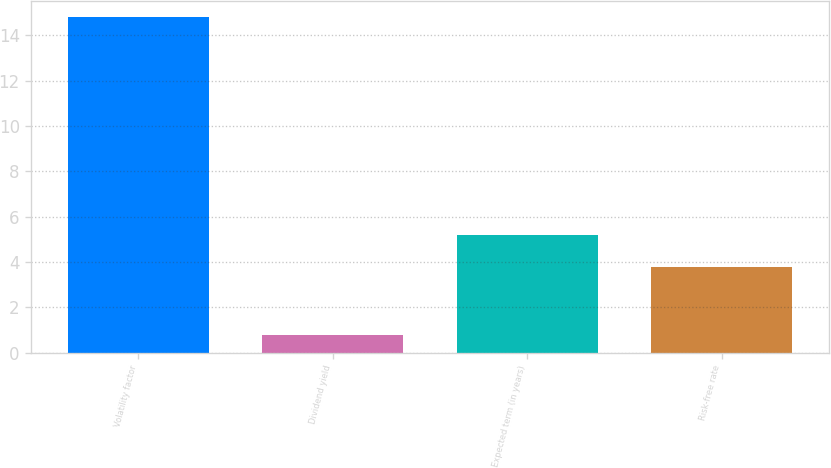<chart> <loc_0><loc_0><loc_500><loc_500><bar_chart><fcel>Volatility factor<fcel>Dividend yield<fcel>Expected term (in years)<fcel>Risk-free rate<nl><fcel>14.8<fcel>0.8<fcel>5.2<fcel>3.8<nl></chart> 